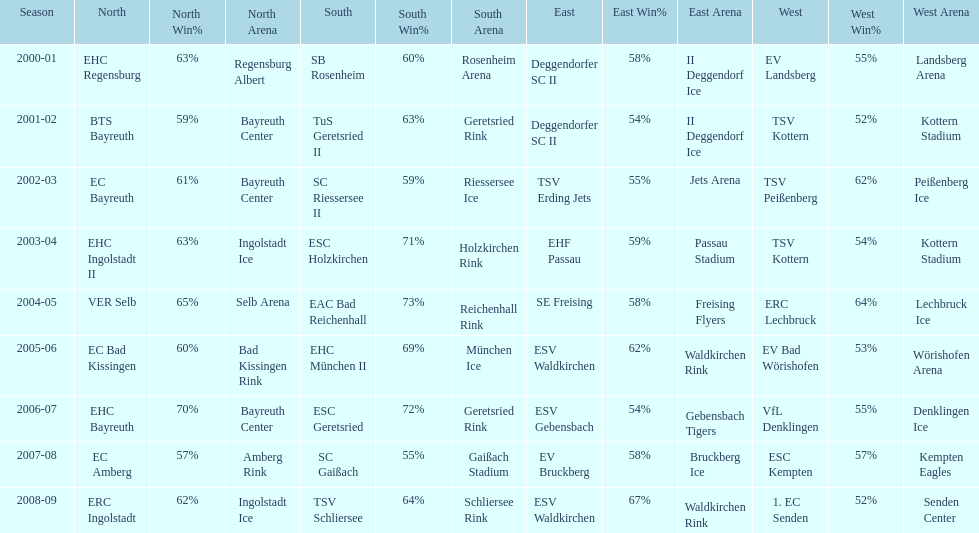Give me the full table as a dictionary. {'header': ['Season', 'North', 'North Win%', 'North Arena', 'South', 'South Win%', 'South Arena', 'East', 'East Win%', 'East Arena', 'West', 'West Win%', 'West Arena'], 'rows': [['2000-01', 'EHC Regensburg', '63%', 'Regensburg Albert', 'SB Rosenheim', '60%', 'Rosenheim Arena', 'Deggendorfer SC II', '58%', 'II Deggendorf Ice', 'EV Landsberg', '55%', 'Landsberg Arena'], ['2001-02', 'BTS Bayreuth', '59%', 'Bayreuth Center', 'TuS Geretsried II', '63%', 'Geretsried Rink', 'Deggendorfer SC II', '54%', 'II Deggendorf Ice', 'TSV Kottern', '52%', 'Kottern Stadium'], ['2002-03', 'EC Bayreuth', '61%', 'Bayreuth Center', 'SC Riessersee II', '59%', 'Riessersee Ice', 'TSV Erding Jets', '55%', 'Jets Arena', 'TSV Peißenberg', '62%', 'Peißenberg Ice'], ['2003-04', 'EHC Ingolstadt II', '63%', 'Ingolstadt Ice', 'ESC Holzkirchen', '71%', 'Holzkirchen Rink', 'EHF Passau', '59%', 'Passau Stadium', 'TSV Kottern', '54%', 'Kottern Stadium'], ['2004-05', 'VER Selb', '65%', 'Selb Arena', 'EAC Bad Reichenhall', '73%', 'Reichenhall Rink', 'SE Freising', '58%', 'Freising Flyers', 'ERC Lechbruck', '64%', 'Lechbruck Ice'], ['2005-06', 'EC Bad Kissingen', '60%', 'Bad Kissingen Rink', 'EHC München II', '69%', 'München Ice', 'ESV Waldkirchen', '62%', 'Waldkirchen Rink', 'EV Bad Wörishofen', '53%', 'Wörishofen Arena'], ['2006-07', 'EHC Bayreuth', '70%', 'Bayreuth Center', 'ESC Geretsried', '72%', 'Geretsried Rink', 'ESV Gebensbach', '54%', 'Gebensbach Tigers', 'VfL Denklingen', '55%', 'Denklingen Ice'], ['2007-08', 'EC Amberg', '57%', 'Amberg Rink', 'SC Gaißach', '55%', 'Gaißach Stadium', 'EV Bruckberg', '58%', 'Bruckberg Ice', 'ESC Kempten', '57%', 'Kempten Eagles'], ['2008-09', 'ERC Ingolstadt', '62%', 'Ingolstadt Ice', 'TSV Schliersee', '64%', 'Schliersee Rink', 'ESV Waldkirchen', '67%', 'Waldkirchen Rink', '1. EC Senden', '52%', 'Senden Center']]} Who won the season in the north before ec bayreuth did in 2002-03? BTS Bayreuth. 